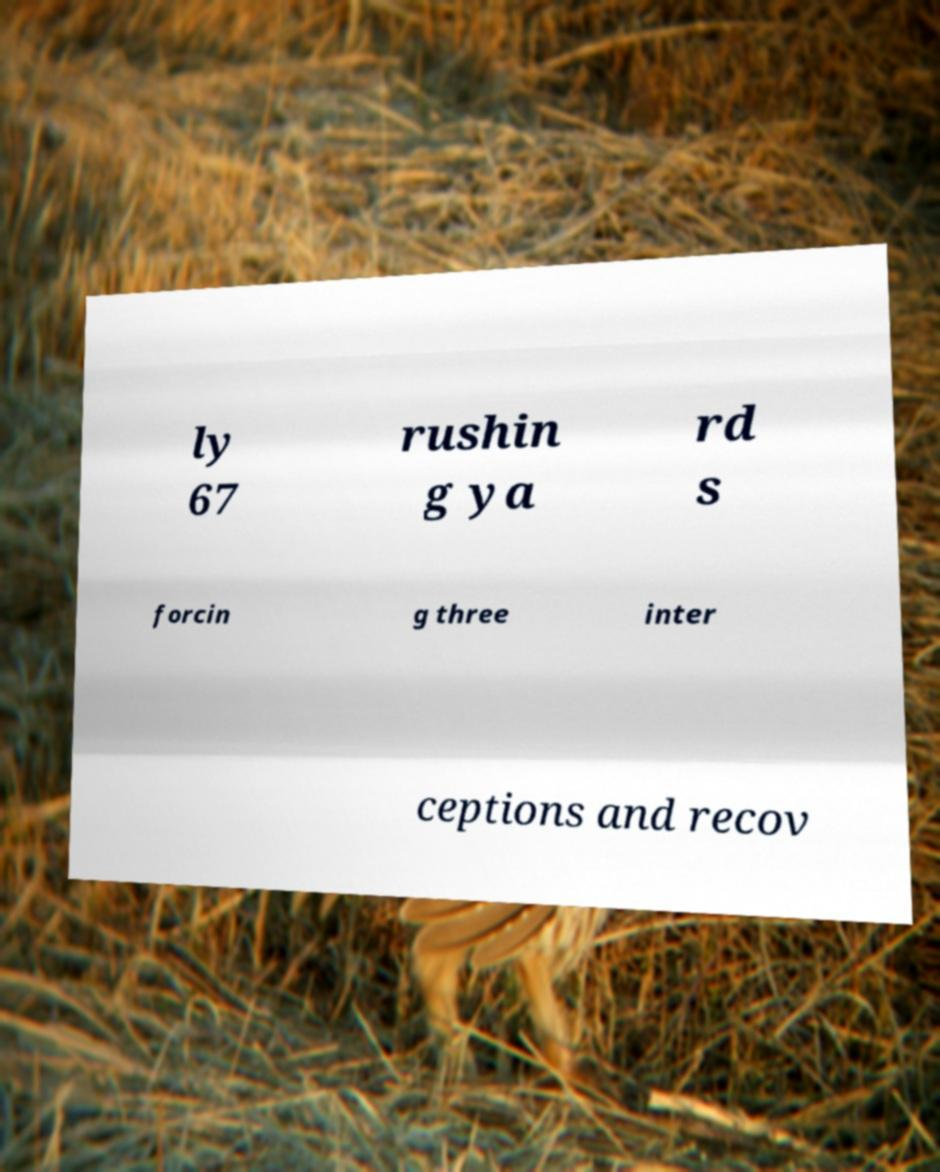Please identify and transcribe the text found in this image. ly 67 rushin g ya rd s forcin g three inter ceptions and recov 